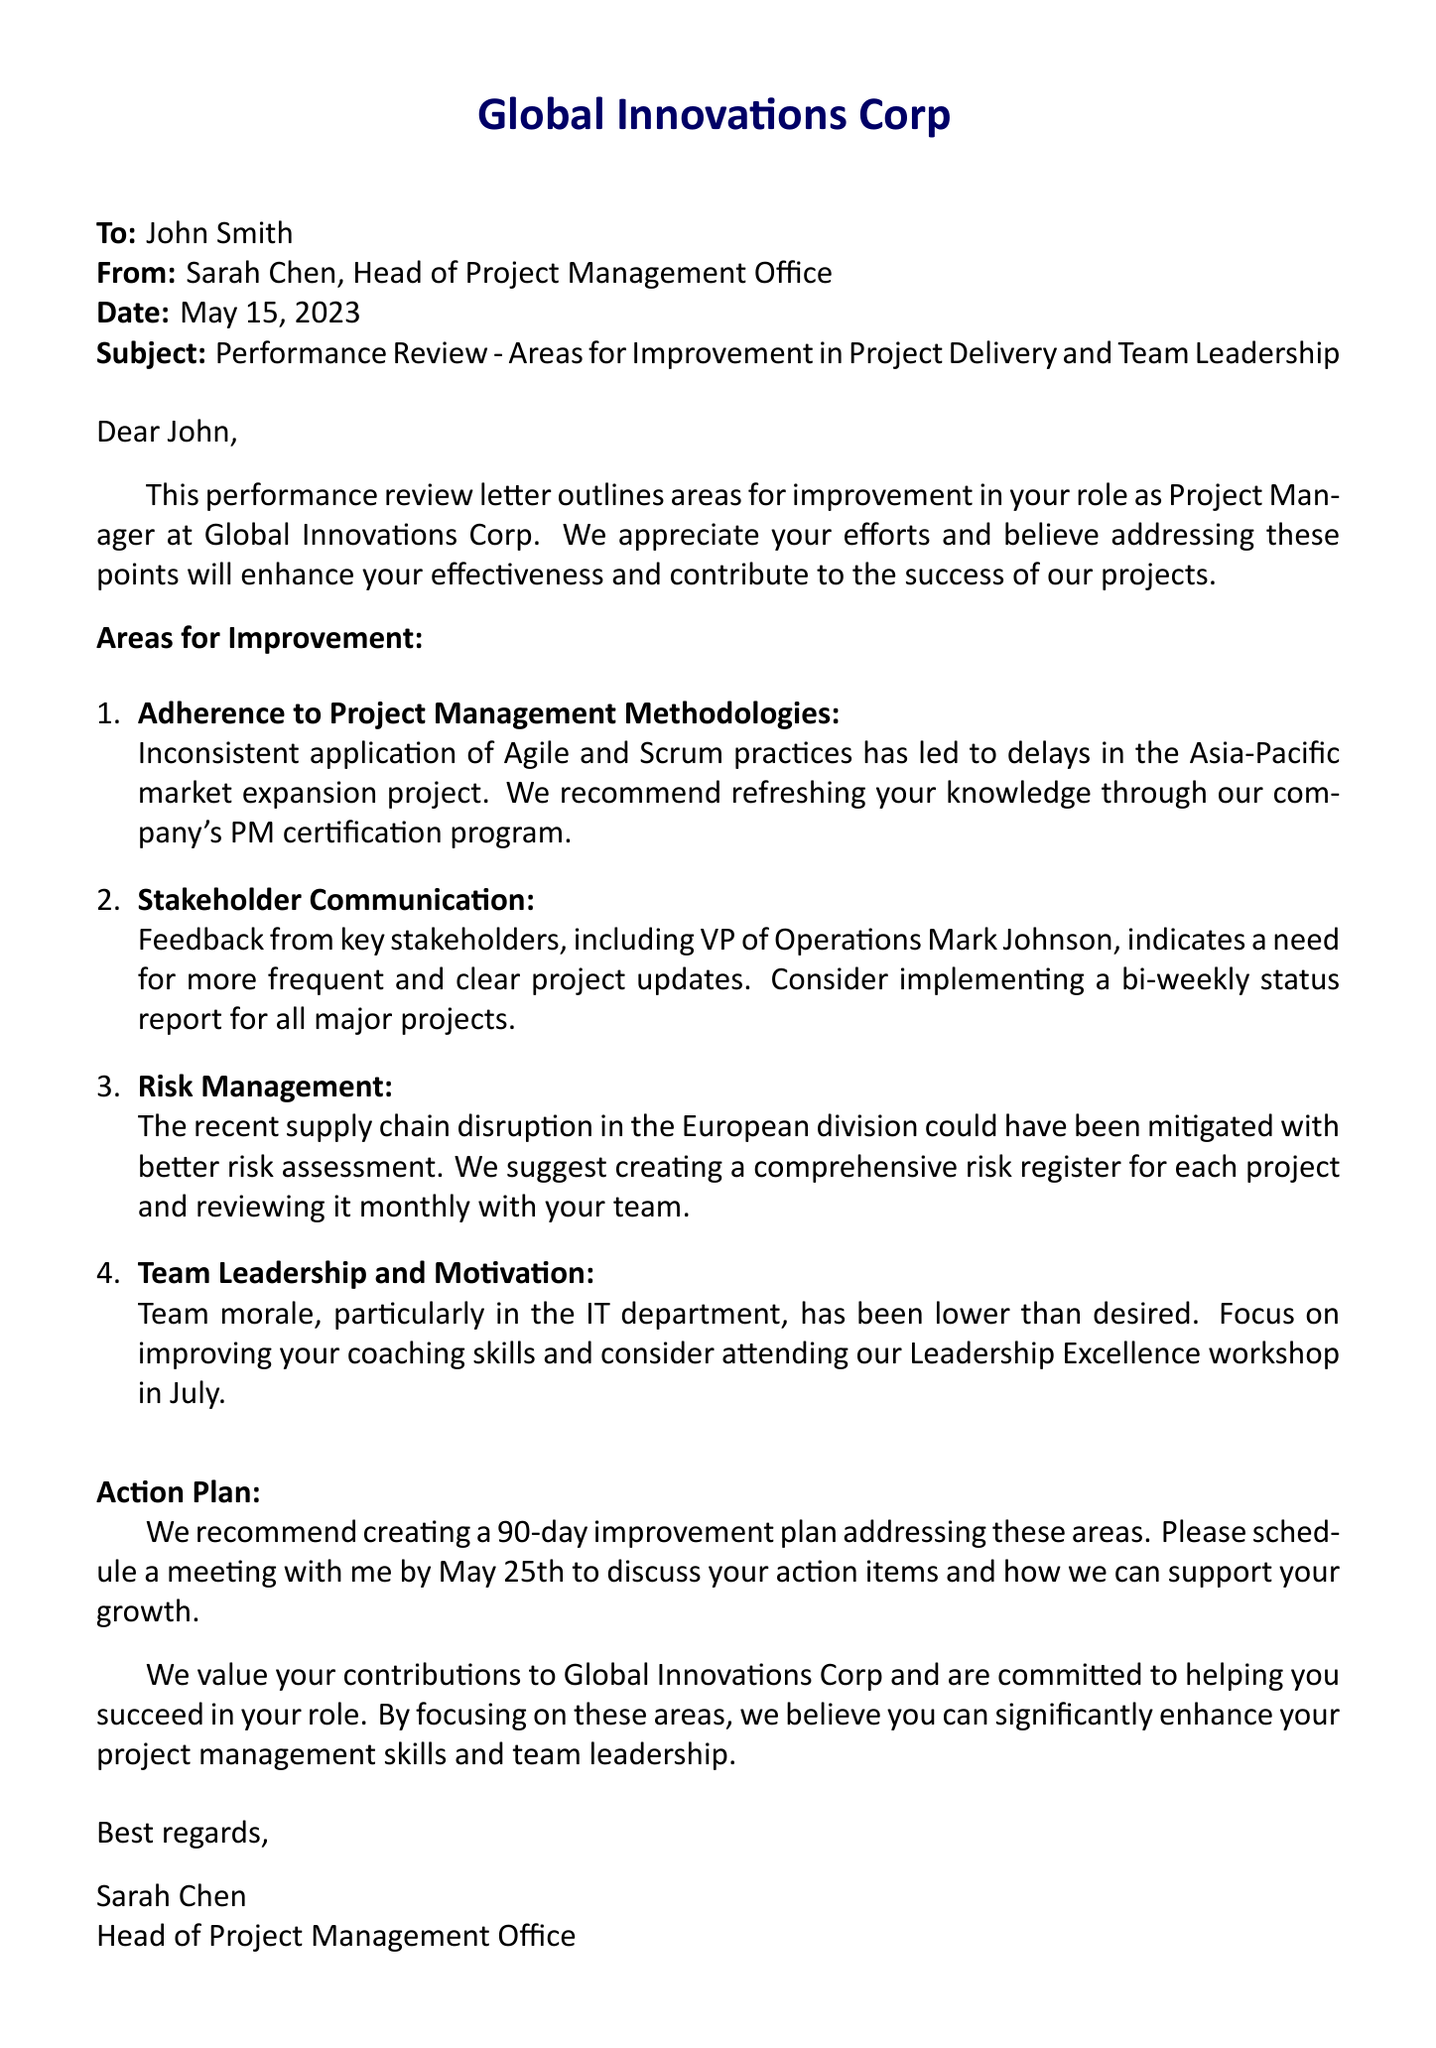What is the recipient's name? The recipient of the performance review letter is specifically mentioned at the beginning of the document.
Answer: John Smith Who is the sender of the letter? The sender is identified in the header of the document, indicating their role within the organization.
Answer: Sarah Chen, Head of Project Management Office What is the date of the letter? The date is stated in the header, showing when the letter was sent.
Answer: May 15, 2023 What is one area for improvement listed? The letter outlines several areas for improvement regarding the recipient's performance as Project Manager.
Answer: Adherence to Project Management Methodologies What is the suggested action for team leadership improvement? The letter indicates a specific workshop aimed at enhancing the recipient's leadership capabilities.
Answer: Leadership Excellence workshop What is the proposed meeting date to discuss the action plan? The document specifies a deadline for scheduling a follow-up meeting to discuss improvements.
Answer: May 25th How many areas for improvement are mentioned? The document lists a specific number of areas for improvement under a designated section.
Answer: Four What is the overall goal of addressing the areas outlined? The primary aim is described towards the end of the letter, focusing on a specific outcome for the recipient's work.
Answer: Enhance project management skills and team leadership What should John consider implementing for stakeholder communication? The letter states a recommendation for enhancing communication frequency and clarity with stakeholders.
Answer: Bi-weekly status report 